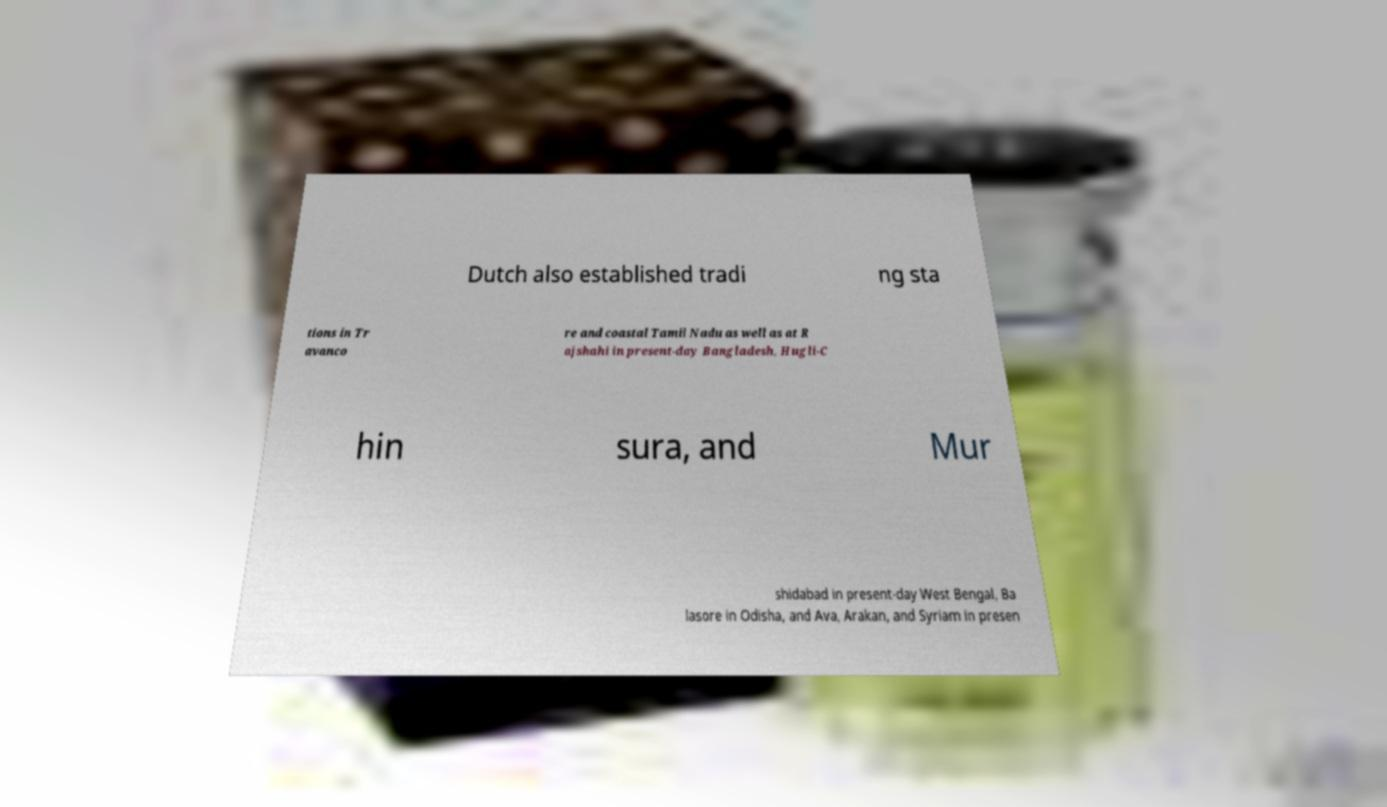There's text embedded in this image that I need extracted. Can you transcribe it verbatim? Dutch also established tradi ng sta tions in Tr avanco re and coastal Tamil Nadu as well as at R ajshahi in present-day Bangladesh, Hugli-C hin sura, and Mur shidabad in present-day West Bengal, Ba lasore in Odisha, and Ava, Arakan, and Syriam in presen 